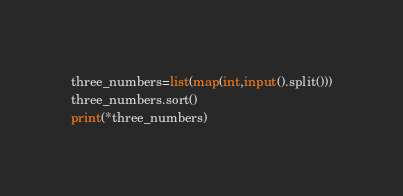<code> <loc_0><loc_0><loc_500><loc_500><_Python_>three_numbers=list(map(int,input().split()))
three_numbers.sort()
print(*three_numbers)
</code> 